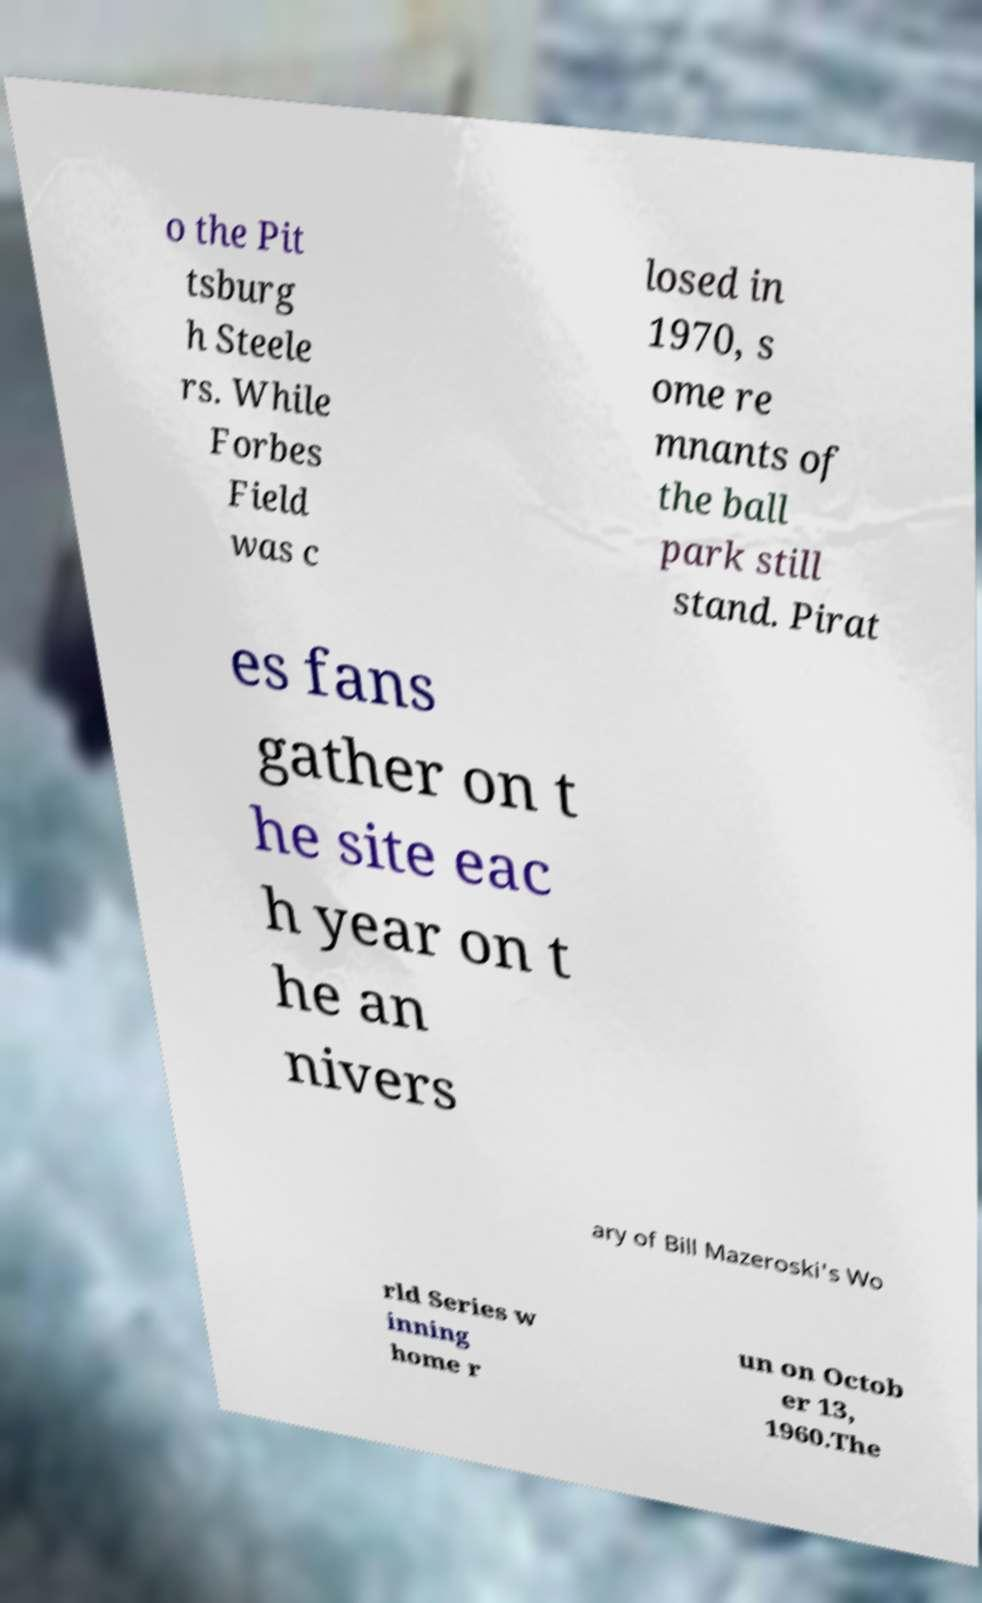For documentation purposes, I need the text within this image transcribed. Could you provide that? o the Pit tsburg h Steele rs. While Forbes Field was c losed in 1970, s ome re mnants of the ball park still stand. Pirat es fans gather on t he site eac h year on t he an nivers ary of Bill Mazeroski's Wo rld Series w inning home r un on Octob er 13, 1960.The 